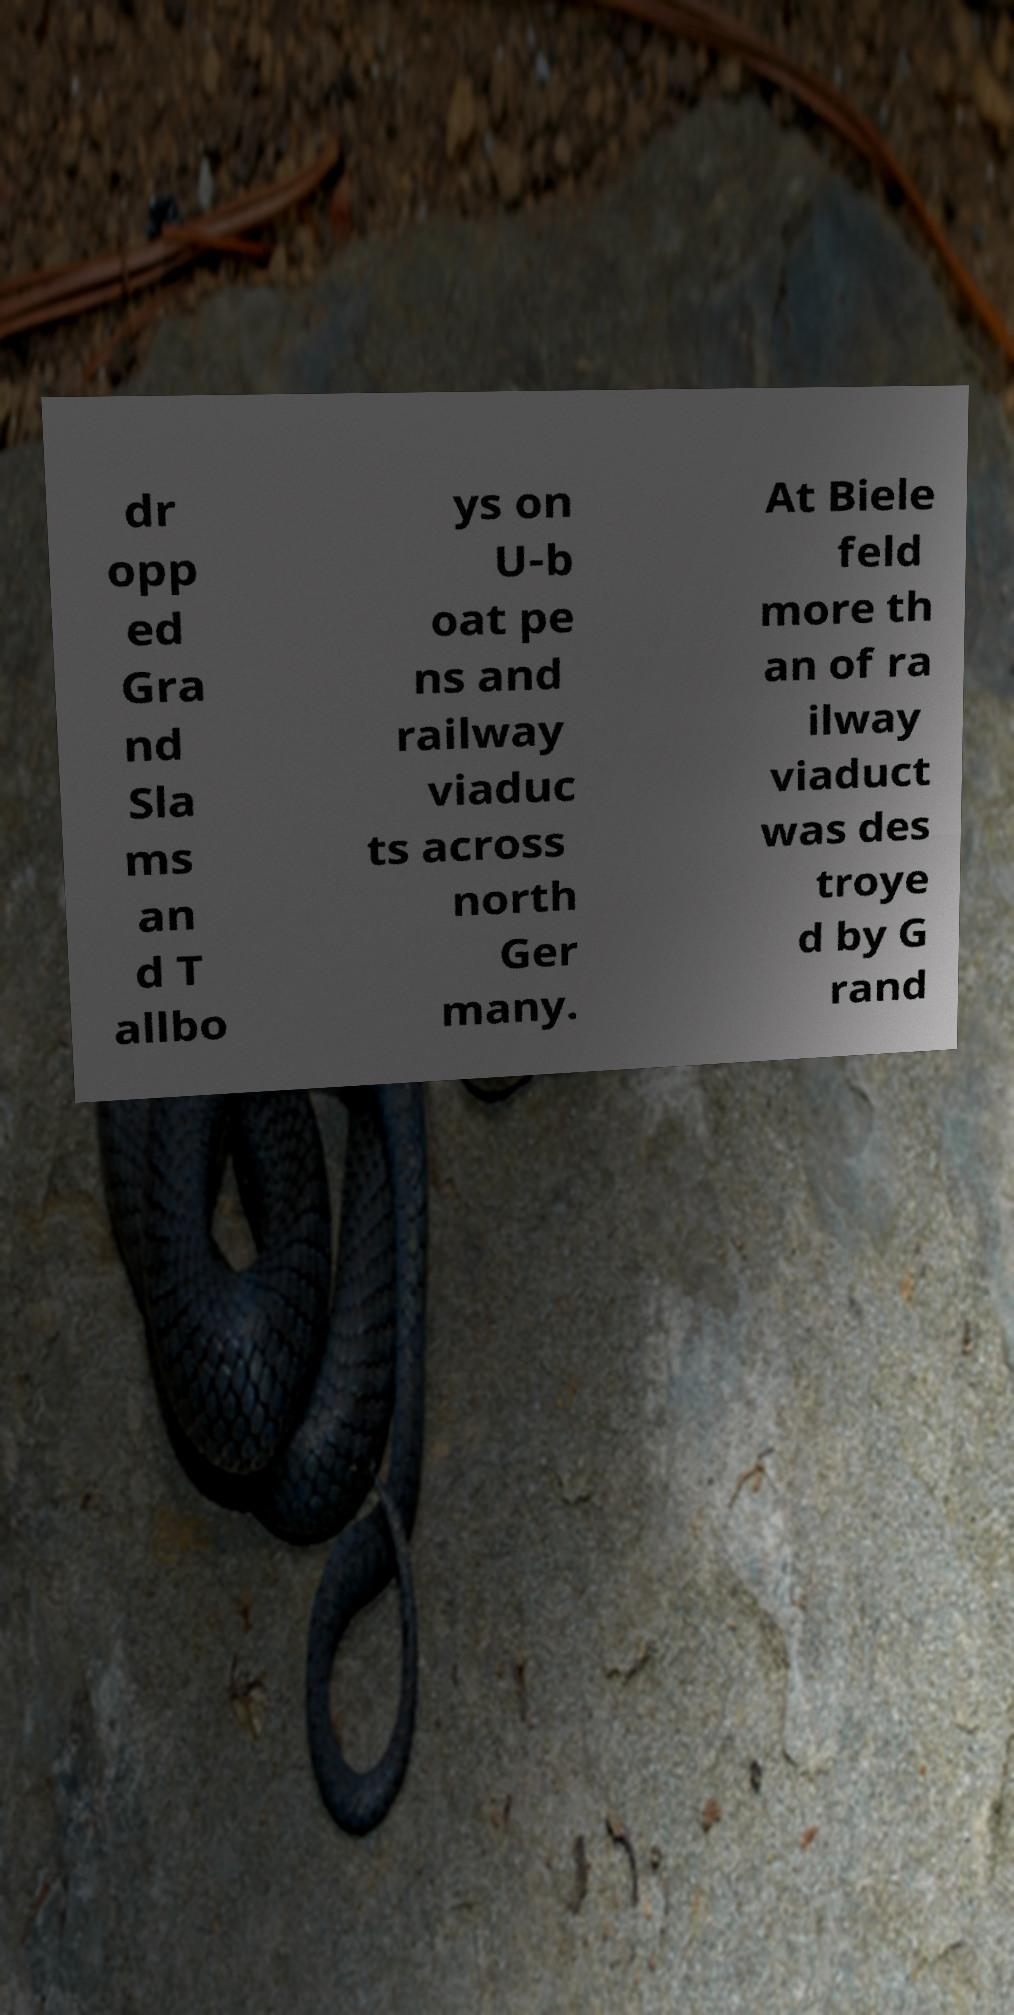Please read and relay the text visible in this image. What does it say? dr opp ed Gra nd Sla ms an d T allbo ys on U-b oat pe ns and railway viaduc ts across north Ger many. At Biele feld more th an of ra ilway viaduct was des troye d by G rand 